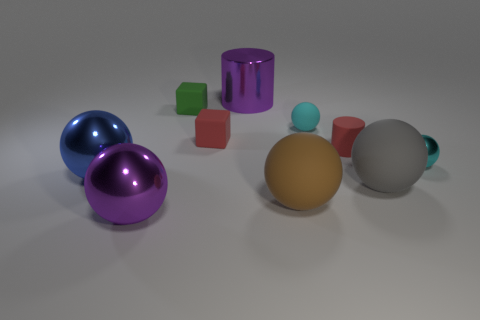Subtract 3 balls. How many balls are left? 3 Subtract all brown cylinders. How many cyan balls are left? 2 Subtract all brown rubber spheres. How many spheres are left? 5 Subtract all brown balls. How many balls are left? 5 Subtract all cyan balls. Subtract all brown cylinders. How many balls are left? 4 Subtract all cubes. How many objects are left? 8 Subtract all big yellow objects. Subtract all purple cylinders. How many objects are left? 9 Add 7 red things. How many red things are left? 9 Add 2 purple shiny cylinders. How many purple shiny cylinders exist? 3 Subtract 0 brown cubes. How many objects are left? 10 